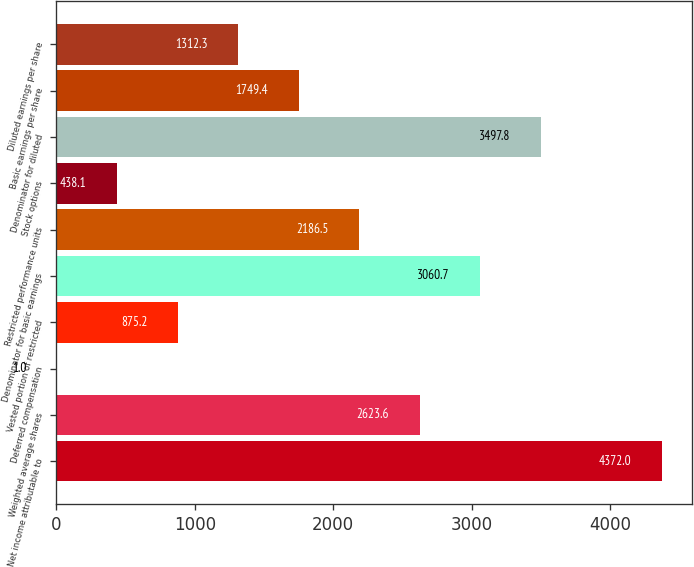<chart> <loc_0><loc_0><loc_500><loc_500><bar_chart><fcel>Net income attributable to<fcel>Weighted average shares<fcel>Deferred compensation<fcel>Vested portion of restricted<fcel>Denominator for basic earnings<fcel>Restricted performance units<fcel>Stock options<fcel>Denominator for diluted<fcel>Basic earnings per share<fcel>Diluted earnings per share<nl><fcel>4372<fcel>2623.6<fcel>1<fcel>875.2<fcel>3060.7<fcel>2186.5<fcel>438.1<fcel>3497.8<fcel>1749.4<fcel>1312.3<nl></chart> 